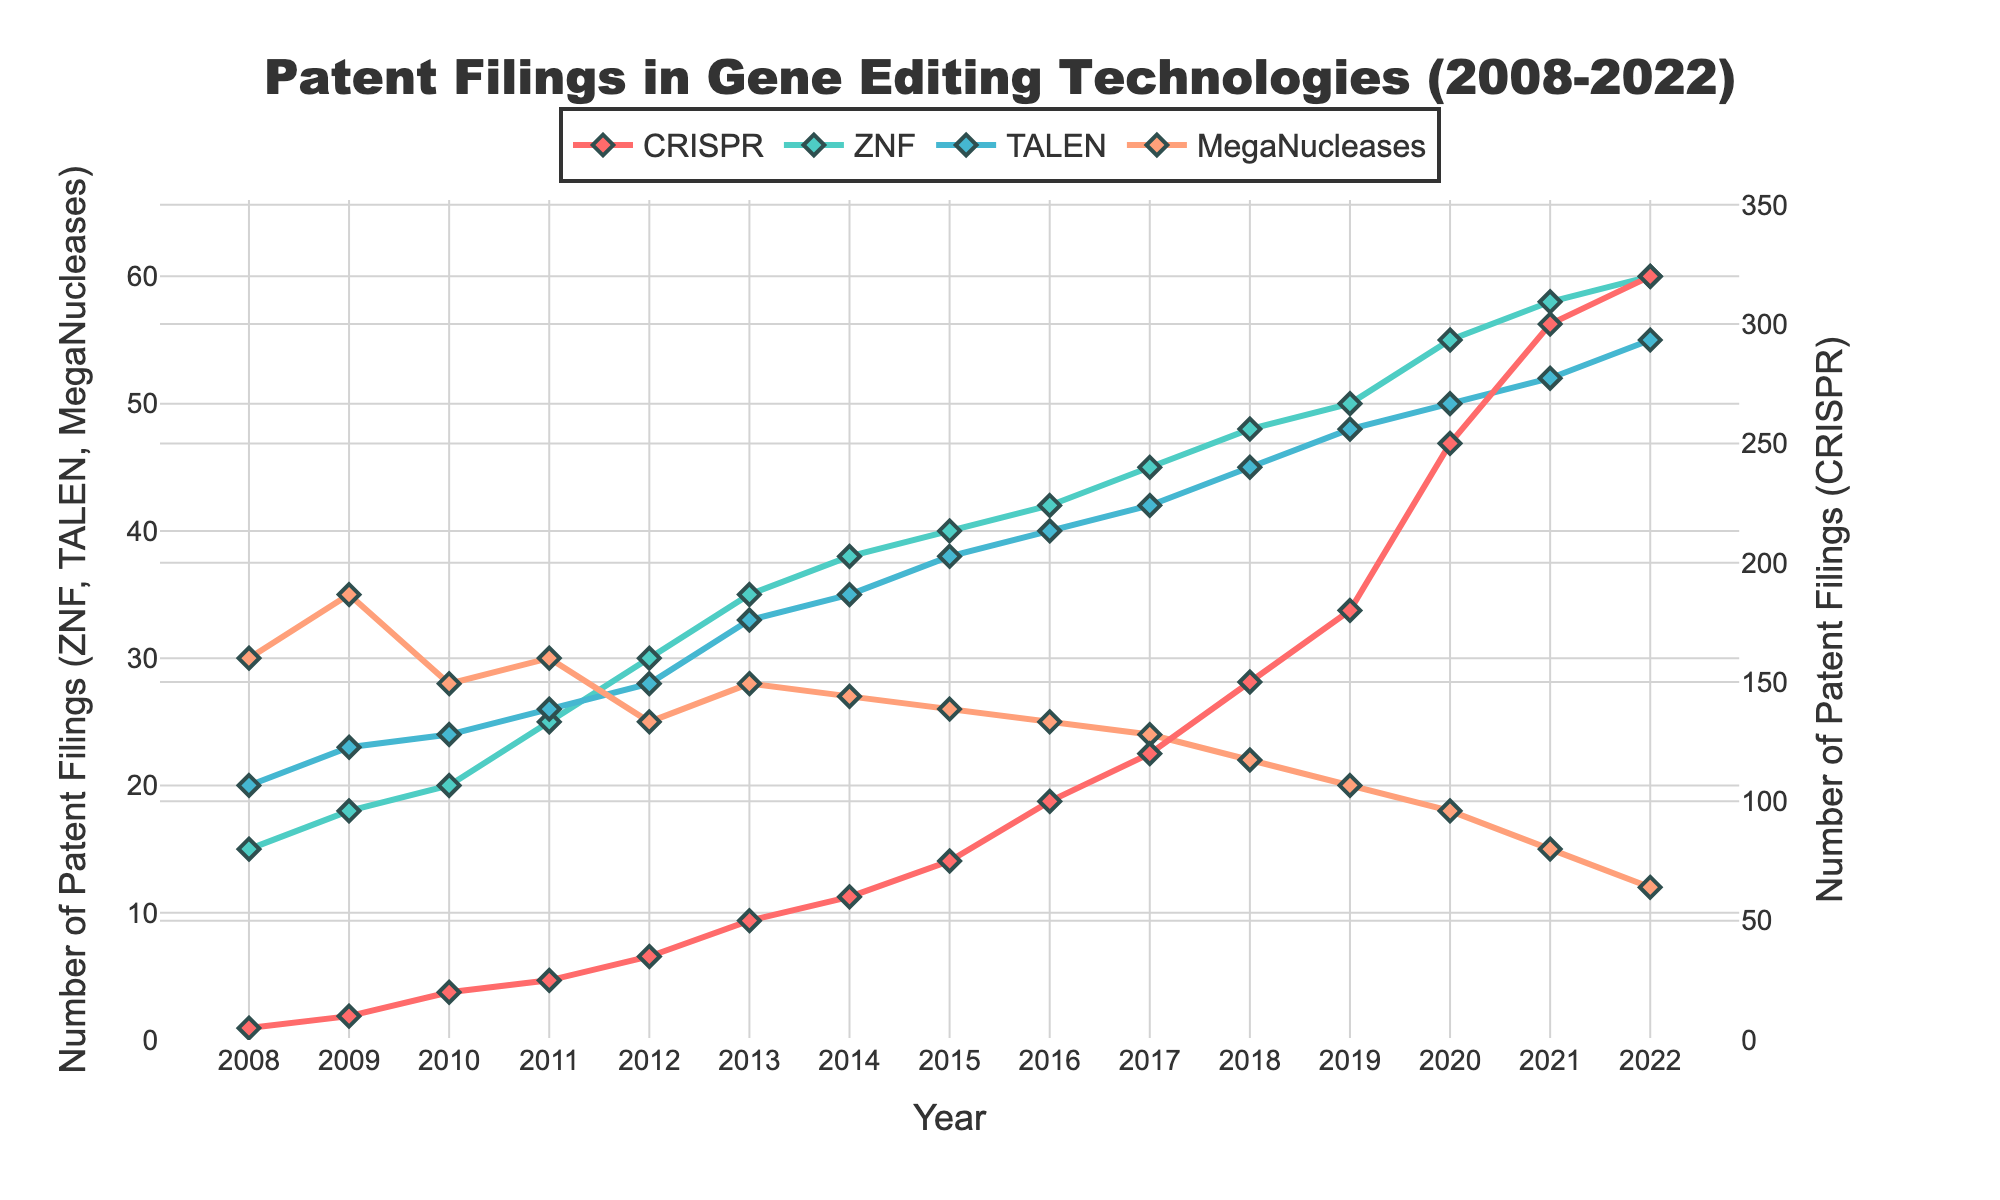What is the title of the figure? The title is located at the top center of the figure and reads "Patent Filings in Gene Editing Technologies (2008-2022)".
Answer: Patent Filings in Gene Editing Technologies (2008-2022) How many technologies are represented in the time series plot? The figure shows four distinct lines, each representing a different gene editing technology: CRISPR, ZNF, TALEN, and MegaNucleases.
Answer: Four Which technology had the highest increase in patent filings between 2008 and 2022? By observing the lines in the figure, CRISPR's line shows the steepest increase, rising from 5 patent filings in 2008 to 320 in 2022, more than any other technology.
Answer: CRISPR What is the range of patent filings for MegaNucleases during the observed period? The vertical axis shows the number of patents, from the lowest point in 2022 (12) to the highest point in 2009 (35) for MegaNucleases.
Answer: 12 to 35 Compare the patent filings for ZNF in 2010 and 2015. Which year had more filings? From the plot, ZNF has around 20 filings in 2010 and 40 filings in 2015, indicating that 2015 had more filings.
Answer: 2015 Calculate the average number of patent filings for TALEN from 2008 to 2022. Sum the patent filings for TALEN across all years (20+23+24+26+28+33+35+38+40+42+45+48+50+52+55) and divide by the number of years (15). Calculation: (20+23+24+26+28+33+35+38+40+42+45+48+50+52+55)/15 = 38.
Answer: 38 Which year did CRISPR experience the largest single-year increase in patent filings? The CRISPR line shows the steepest single-year increase between 2019 and 2020, jumping from 180 to 250 filings.
Answer: 2019 to 2020 In which year did TALEN reach its peak number of patent filings? By examining the line for TALEN on the graph, it reaches its highest point at 55 filings in 2022.
Answer: 2022 How does the trajectory of ZNF patent filings compare to that of MegaNucleases over the span of 15 years? ZNF filings initially rise to about 60 in 2022, peaking earlier and staying relatively stable, whereas MegaNucleases start high in 2008 and steadily decline to 12 by 2022.
Answer: ZNF rises and stabilizes; MegaNucleases decline 